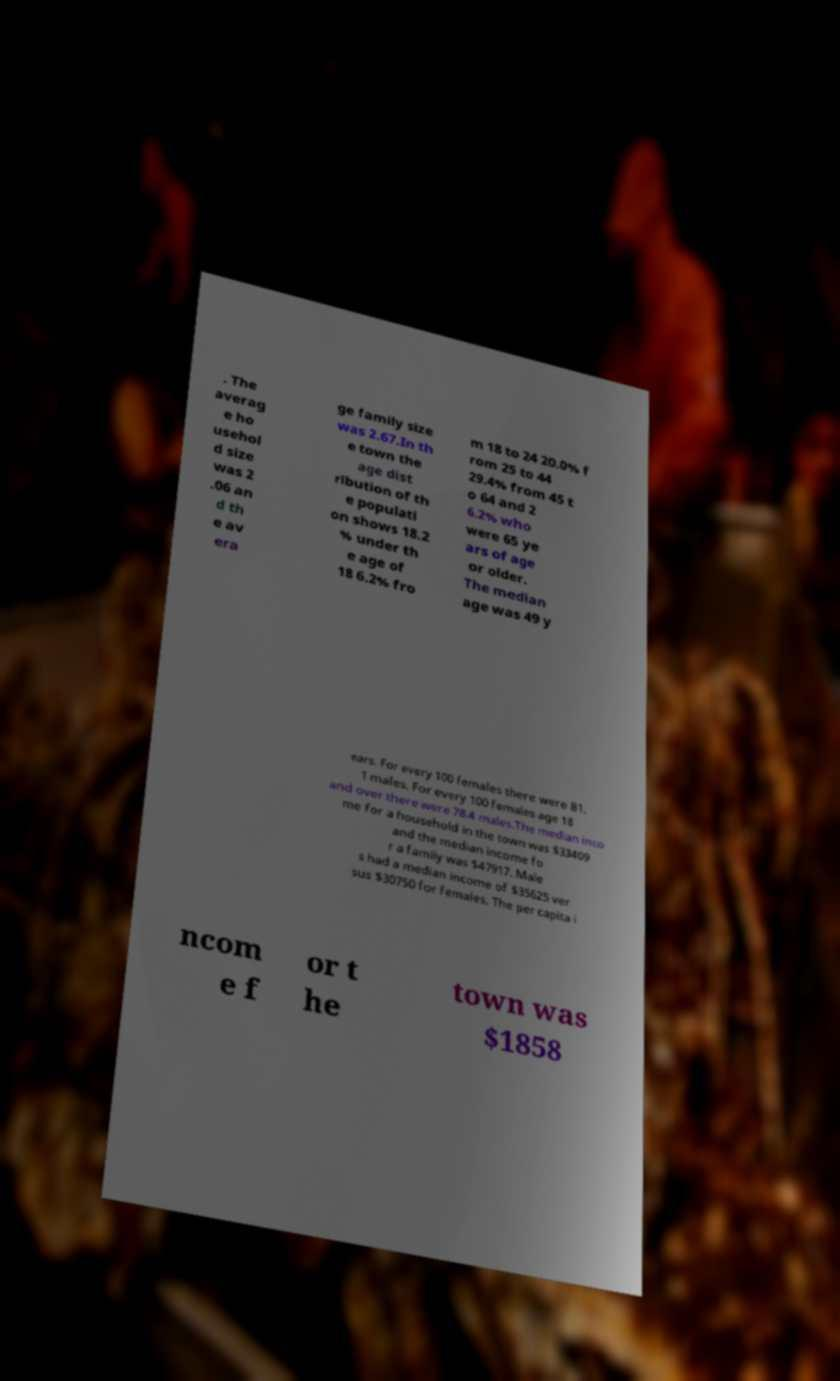I need the written content from this picture converted into text. Can you do that? . The averag e ho usehol d size was 2 .06 an d th e av era ge family size was 2.67.In th e town the age dist ribution of th e populati on shows 18.2 % under th e age of 18 6.2% fro m 18 to 24 20.0% f rom 25 to 44 29.4% from 45 t o 64 and 2 6.2% who were 65 ye ars of age or older. The median age was 49 y ears. For every 100 females there were 81. 1 males. For every 100 females age 18 and over there were 78.4 males.The median inco me for a household in the town was $33409 and the median income fo r a family was $47917. Male s had a median income of $35625 ver sus $30750 for females. The per capita i ncom e f or t he town was $1858 